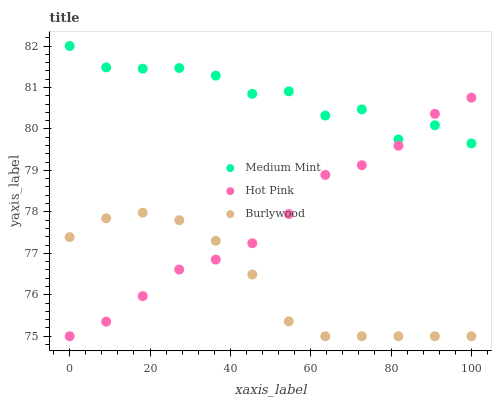Does Burlywood have the minimum area under the curve?
Answer yes or no. Yes. Does Medium Mint have the maximum area under the curve?
Answer yes or no. Yes. Does Hot Pink have the minimum area under the curve?
Answer yes or no. No. Does Hot Pink have the maximum area under the curve?
Answer yes or no. No. Is Burlywood the smoothest?
Answer yes or no. Yes. Is Medium Mint the roughest?
Answer yes or no. Yes. Is Hot Pink the smoothest?
Answer yes or no. No. Is Hot Pink the roughest?
Answer yes or no. No. Does Burlywood have the lowest value?
Answer yes or no. Yes. Does Medium Mint have the highest value?
Answer yes or no. Yes. Does Hot Pink have the highest value?
Answer yes or no. No. Is Burlywood less than Medium Mint?
Answer yes or no. Yes. Is Medium Mint greater than Burlywood?
Answer yes or no. Yes. Does Medium Mint intersect Hot Pink?
Answer yes or no. Yes. Is Medium Mint less than Hot Pink?
Answer yes or no. No. Is Medium Mint greater than Hot Pink?
Answer yes or no. No. Does Burlywood intersect Medium Mint?
Answer yes or no. No. 